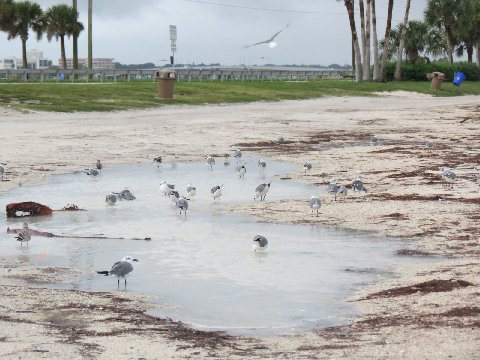<image>What sort of disaster is happening? It is ambiguous what sort of disaster is happening. It could be a drought or a flood. What sort of disaster is happening? It is unclear what sort of disaster is happening. It can be seen as a drought or a flood. 